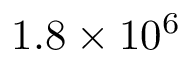Convert formula to latex. <formula><loc_0><loc_0><loc_500><loc_500>1 . 8 \times 1 0 ^ { 6 }</formula> 